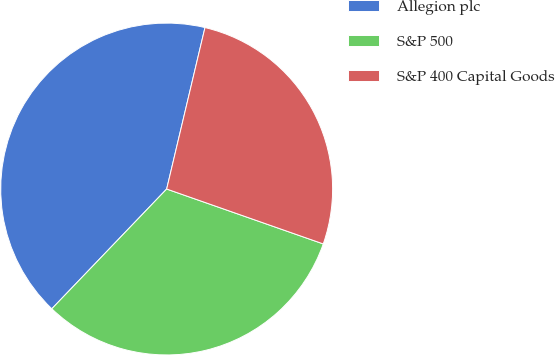<chart> <loc_0><loc_0><loc_500><loc_500><pie_chart><fcel>Allegion plc<fcel>S&P 500<fcel>S&P 400 Capital Goods<nl><fcel>41.54%<fcel>31.8%<fcel>26.66%<nl></chart> 